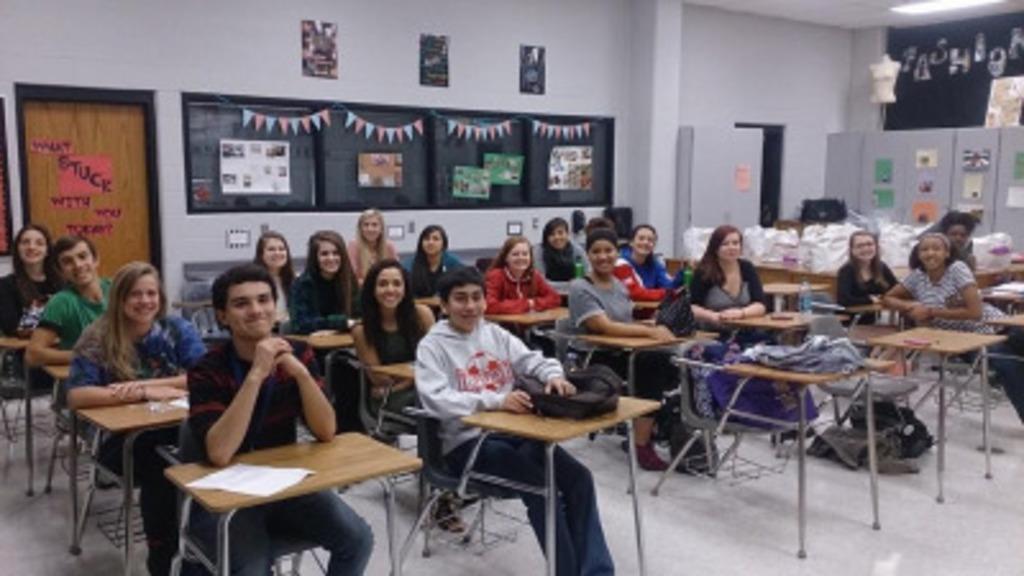Could you give a brief overview of what you see in this image? This is a picture taken in a room, there are a group of people sitting on a chair in front of these people there are tables on the table there are paper, books and bags. Background of this people is a wall and a notice board. 